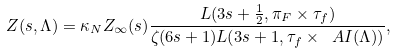<formula> <loc_0><loc_0><loc_500><loc_500>Z ( s , \Lambda ) = \kappa _ { N } Z _ { \infty } ( s ) \frac { L ( 3 s + \frac { 1 } { 2 } , \pi _ { F } \times \tau _ { f } ) } { \zeta ( 6 s + 1 ) L ( 3 s + 1 , \tau _ { f } \times \ A I ( \Lambda ) ) } ,</formula> 